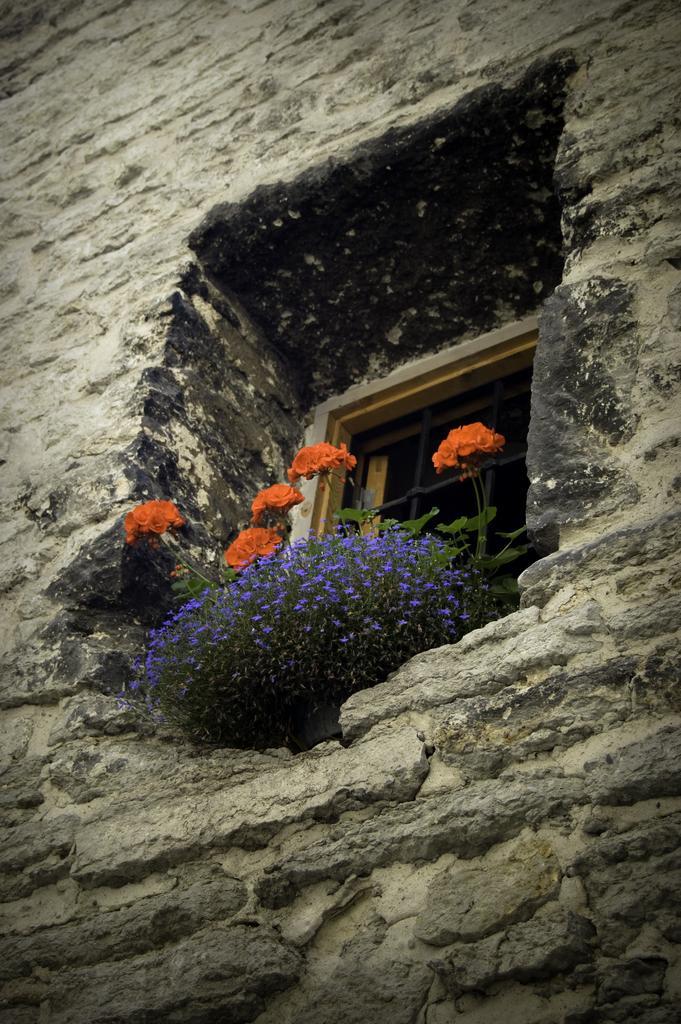Describe this image in one or two sentences. In this picture there is a window in the center of the image and there are flowers in front of the window. 